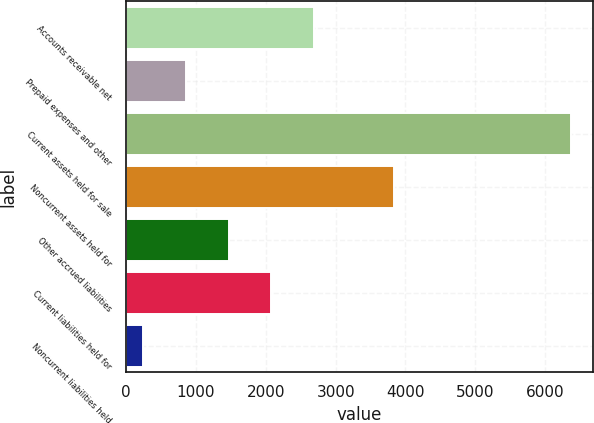Convert chart to OTSL. <chart><loc_0><loc_0><loc_500><loc_500><bar_chart><fcel>Accounts receivable net<fcel>Prepaid expenses and other<fcel>Current assets held for sale<fcel>Noncurrent assets held for<fcel>Other accrued liabilities<fcel>Current liabilities held for<fcel>Noncurrent liabilities held<nl><fcel>2693.66<fcel>855.29<fcel>6370.4<fcel>3842.2<fcel>1468.08<fcel>2080.87<fcel>242.5<nl></chart> 